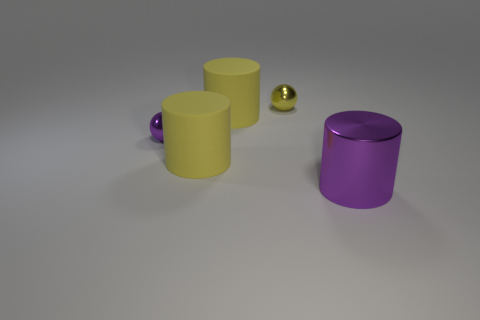What number of shiny objects are behind the large purple thing and on the right side of the purple shiny ball?
Your answer should be very brief. 1. What number of other things are the same size as the yellow shiny ball?
Your response must be concise. 1. There is a purple shiny object that is behind the big metal cylinder; is its shape the same as the small thing that is to the right of the purple metallic sphere?
Your response must be concise. Yes. How many things are either small yellow shiny cylinders or big things in front of the small purple metallic sphere?
Offer a terse response. 2. There is a large object that is made of the same material as the purple sphere; what color is it?
Offer a very short reply. Purple. How many objects are cylinders or tiny purple balls?
Give a very brief answer. 4. Is the size of the yellow metallic object the same as the purple metallic object behind the large shiny thing?
Your response must be concise. Yes. What is the color of the small metal sphere left of the yellow matte cylinder behind the ball that is in front of the yellow metal sphere?
Your answer should be very brief. Purple. The metallic cylinder has what color?
Provide a short and direct response. Purple. Are there more big purple cylinders that are left of the large purple thing than metallic things that are on the right side of the yellow ball?
Provide a short and direct response. No. 